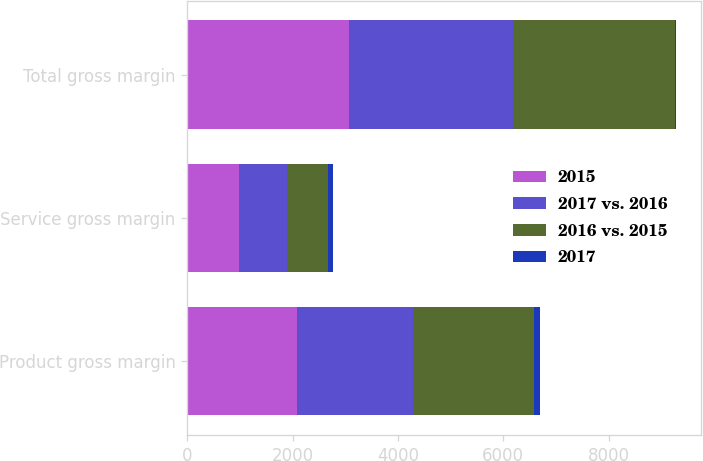Convert chart to OTSL. <chart><loc_0><loc_0><loc_500><loc_500><stacked_bar_chart><ecel><fcel>Product gross margin<fcel>Service gross margin<fcel>Total gross margin<nl><fcel>2015<fcel>2085.3<fcel>986.8<fcel>3072.1<nl><fcel>2017 vs. 2016<fcel>2202.7<fcel>901.8<fcel>3104.5<nl><fcel>2016 vs. 2015<fcel>2293.5<fcel>785.1<fcel>3078.6<nl><fcel>2017<fcel>117.4<fcel>85<fcel>32.4<nl></chart> 